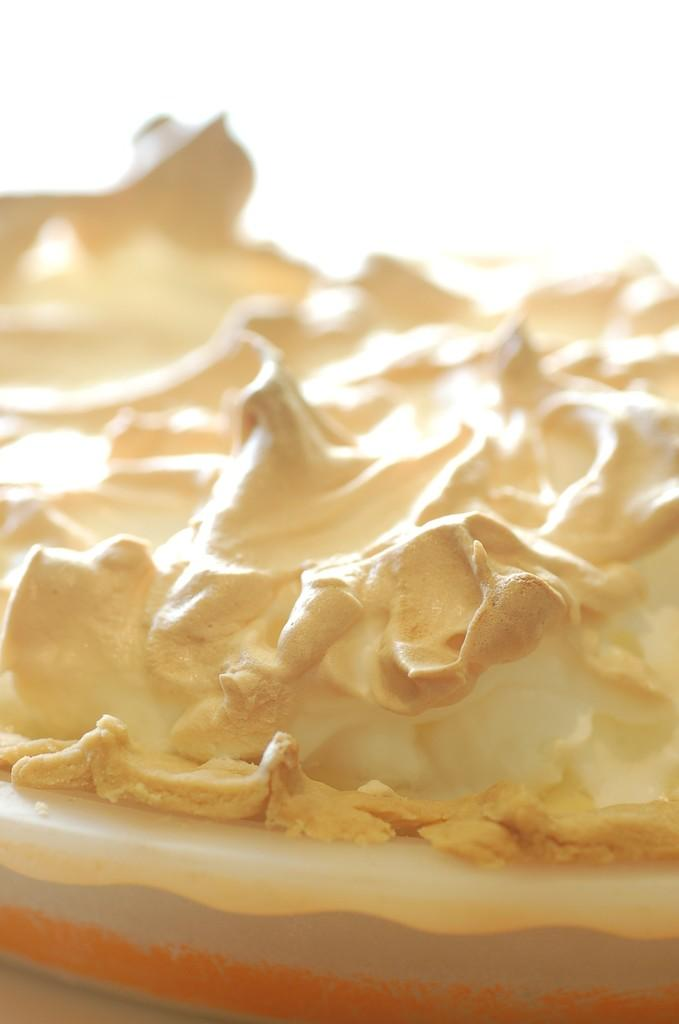What is the color of the object in the image? The object in the image is cream-colored. How is the object positioned in the image? The object is kept in a tray. What caption is written on the object in the image? There is no caption written on the object in the image, as it is not a text-based item. 